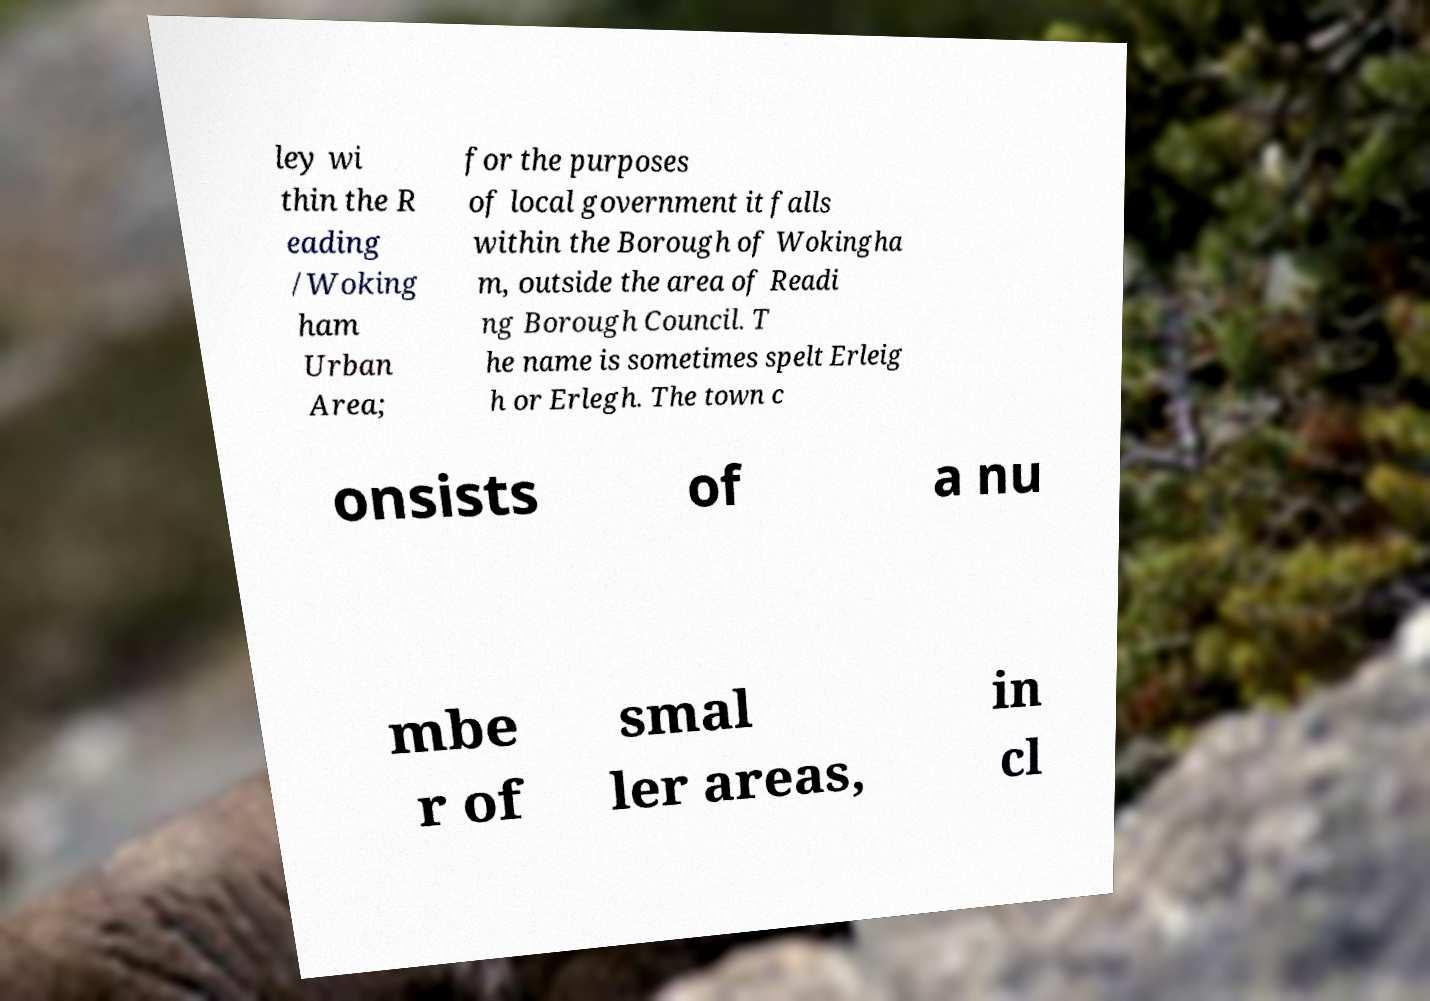I need the written content from this picture converted into text. Can you do that? ley wi thin the R eading /Woking ham Urban Area; for the purposes of local government it falls within the Borough of Wokingha m, outside the area of Readi ng Borough Council. T he name is sometimes spelt Erleig h or Erlegh. The town c onsists of a nu mbe r of smal ler areas, in cl 